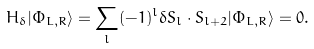Convert formula to latex. <formula><loc_0><loc_0><loc_500><loc_500>H _ { \delta } | \Phi _ { L , R } \rangle = \sum _ { l } ( - 1 ) ^ { l } \delta { S } _ { l } \cdot { S } _ { l + 2 } | \Phi _ { L , R } \rangle = 0 .</formula> 